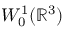Convert formula to latex. <formula><loc_0><loc_0><loc_500><loc_500>W _ { 0 } ^ { 1 } ( { \mathbb { R } } ^ { 3 } )</formula> 